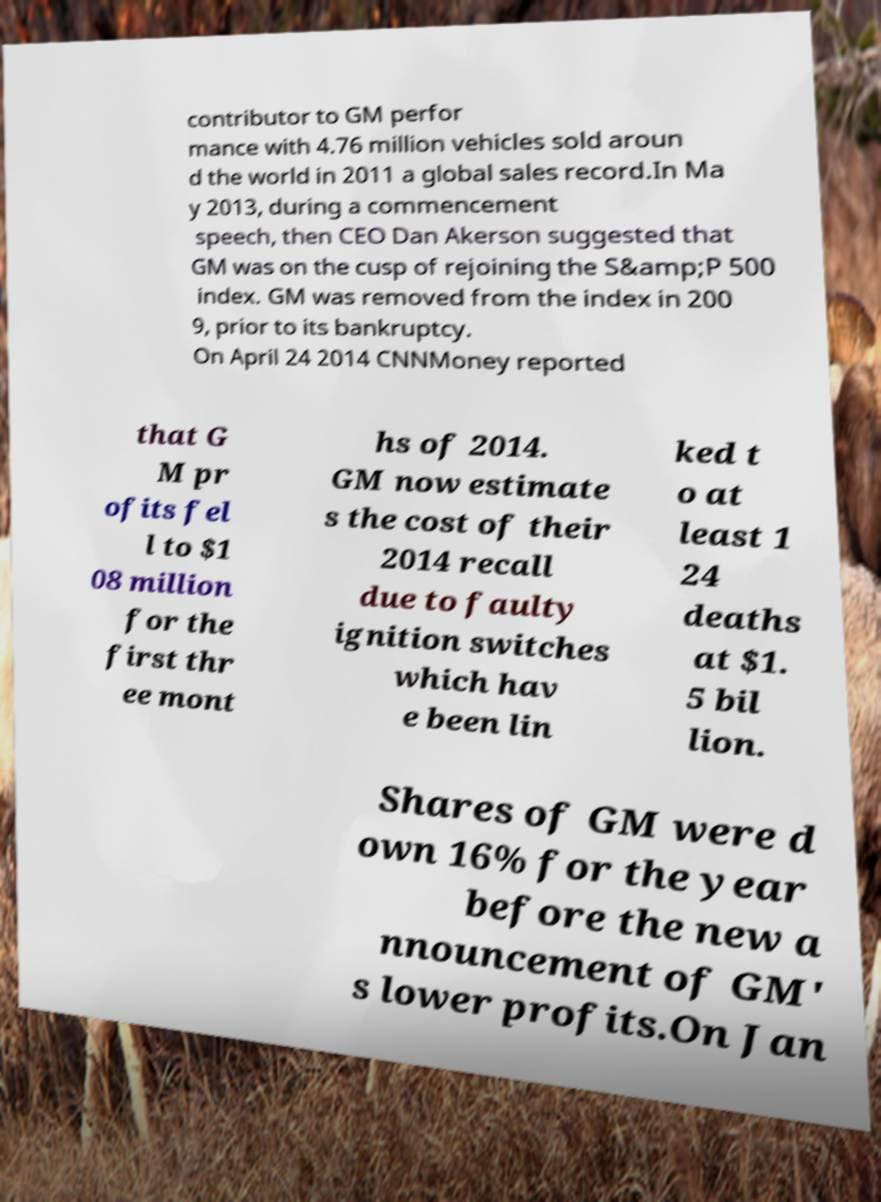What messages or text are displayed in this image? I need them in a readable, typed format. contributor to GM perfor mance with 4.76 million vehicles sold aroun d the world in 2011 a global sales record.In Ma y 2013, during a commencement speech, then CEO Dan Akerson suggested that GM was on the cusp of rejoining the S&amp;P 500 index. GM was removed from the index in 200 9, prior to its bankruptcy. On April 24 2014 CNNMoney reported that G M pr ofits fel l to $1 08 million for the first thr ee mont hs of 2014. GM now estimate s the cost of their 2014 recall due to faulty ignition switches which hav e been lin ked t o at least 1 24 deaths at $1. 5 bil lion. Shares of GM were d own 16% for the year before the new a nnouncement of GM' s lower profits.On Jan 